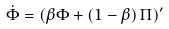<formula> <loc_0><loc_0><loc_500><loc_500>\dot { \Phi } = \left ( \beta \Phi + \left ( 1 - \beta \right ) \Pi \right ) ^ { \prime }</formula> 